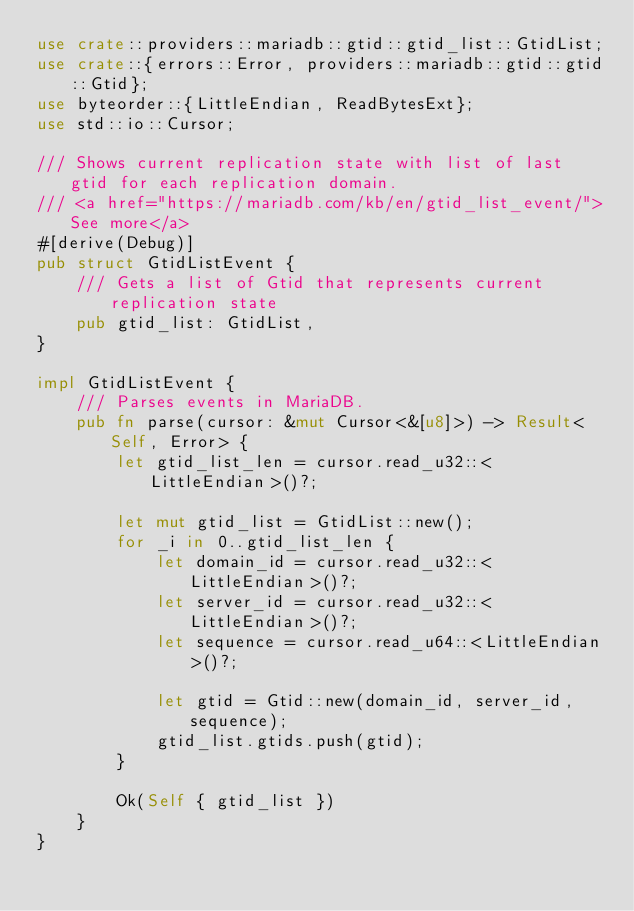Convert code to text. <code><loc_0><loc_0><loc_500><loc_500><_Rust_>use crate::providers::mariadb::gtid::gtid_list::GtidList;
use crate::{errors::Error, providers::mariadb::gtid::gtid::Gtid};
use byteorder::{LittleEndian, ReadBytesExt};
use std::io::Cursor;

/// Shows current replication state with list of last gtid for each replication domain.
/// <a href="https://mariadb.com/kb/en/gtid_list_event/">See more</a>
#[derive(Debug)]
pub struct GtidListEvent {
    /// Gets a list of Gtid that represents current replication state
    pub gtid_list: GtidList,
}

impl GtidListEvent {
    /// Parses events in MariaDB.
    pub fn parse(cursor: &mut Cursor<&[u8]>) -> Result<Self, Error> {
        let gtid_list_len = cursor.read_u32::<LittleEndian>()?;

        let mut gtid_list = GtidList::new();
        for _i in 0..gtid_list_len {
            let domain_id = cursor.read_u32::<LittleEndian>()?;
            let server_id = cursor.read_u32::<LittleEndian>()?;
            let sequence = cursor.read_u64::<LittleEndian>()?;

            let gtid = Gtid::new(domain_id, server_id, sequence);
            gtid_list.gtids.push(gtid);
        }

        Ok(Self { gtid_list })
    }
}
</code> 